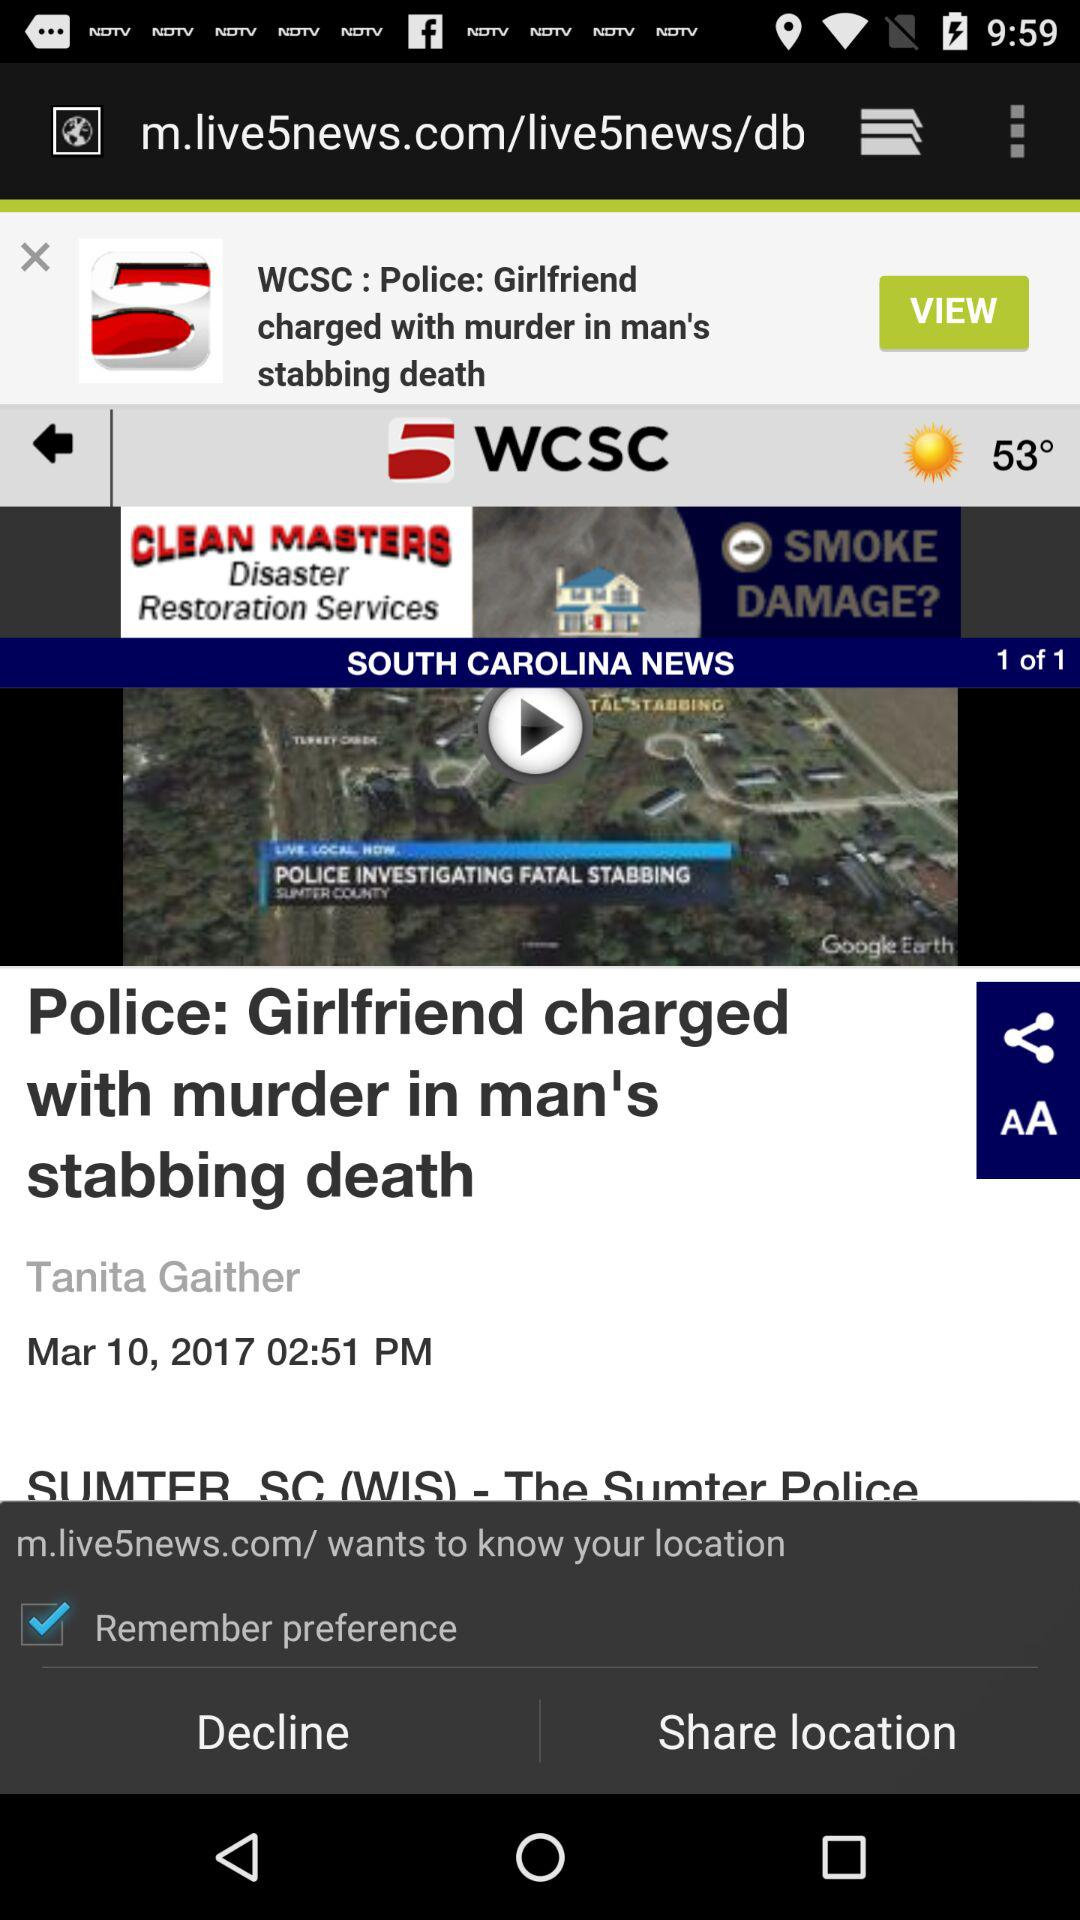What is the date of the video titled "Police: Girlfriend charged with murder in man's stabbing death"? The date of the video titled "Police: Girlfriend charged with murder in man's stabbing death" is March 10, 2017. 